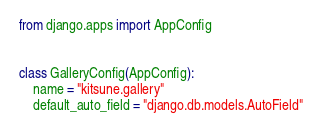<code> <loc_0><loc_0><loc_500><loc_500><_Python_>from django.apps import AppConfig


class GalleryConfig(AppConfig):
    name = "kitsune.gallery"
    default_auto_field = "django.db.models.AutoField"
</code> 